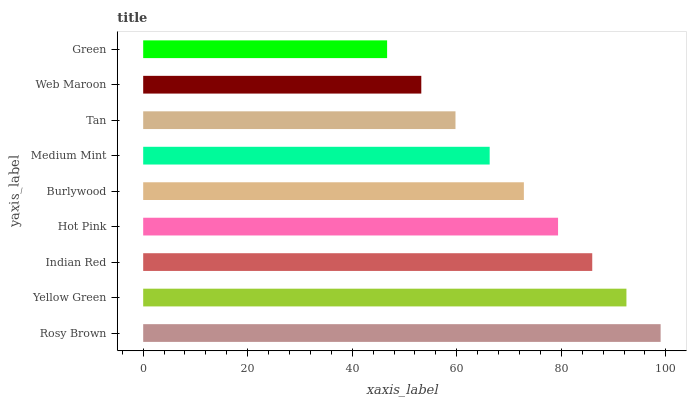Is Green the minimum?
Answer yes or no. Yes. Is Rosy Brown the maximum?
Answer yes or no. Yes. Is Yellow Green the minimum?
Answer yes or no. No. Is Yellow Green the maximum?
Answer yes or no. No. Is Rosy Brown greater than Yellow Green?
Answer yes or no. Yes. Is Yellow Green less than Rosy Brown?
Answer yes or no. Yes. Is Yellow Green greater than Rosy Brown?
Answer yes or no. No. Is Rosy Brown less than Yellow Green?
Answer yes or no. No. Is Burlywood the high median?
Answer yes or no. Yes. Is Burlywood the low median?
Answer yes or no. Yes. Is Medium Mint the high median?
Answer yes or no. No. Is Web Maroon the low median?
Answer yes or no. No. 